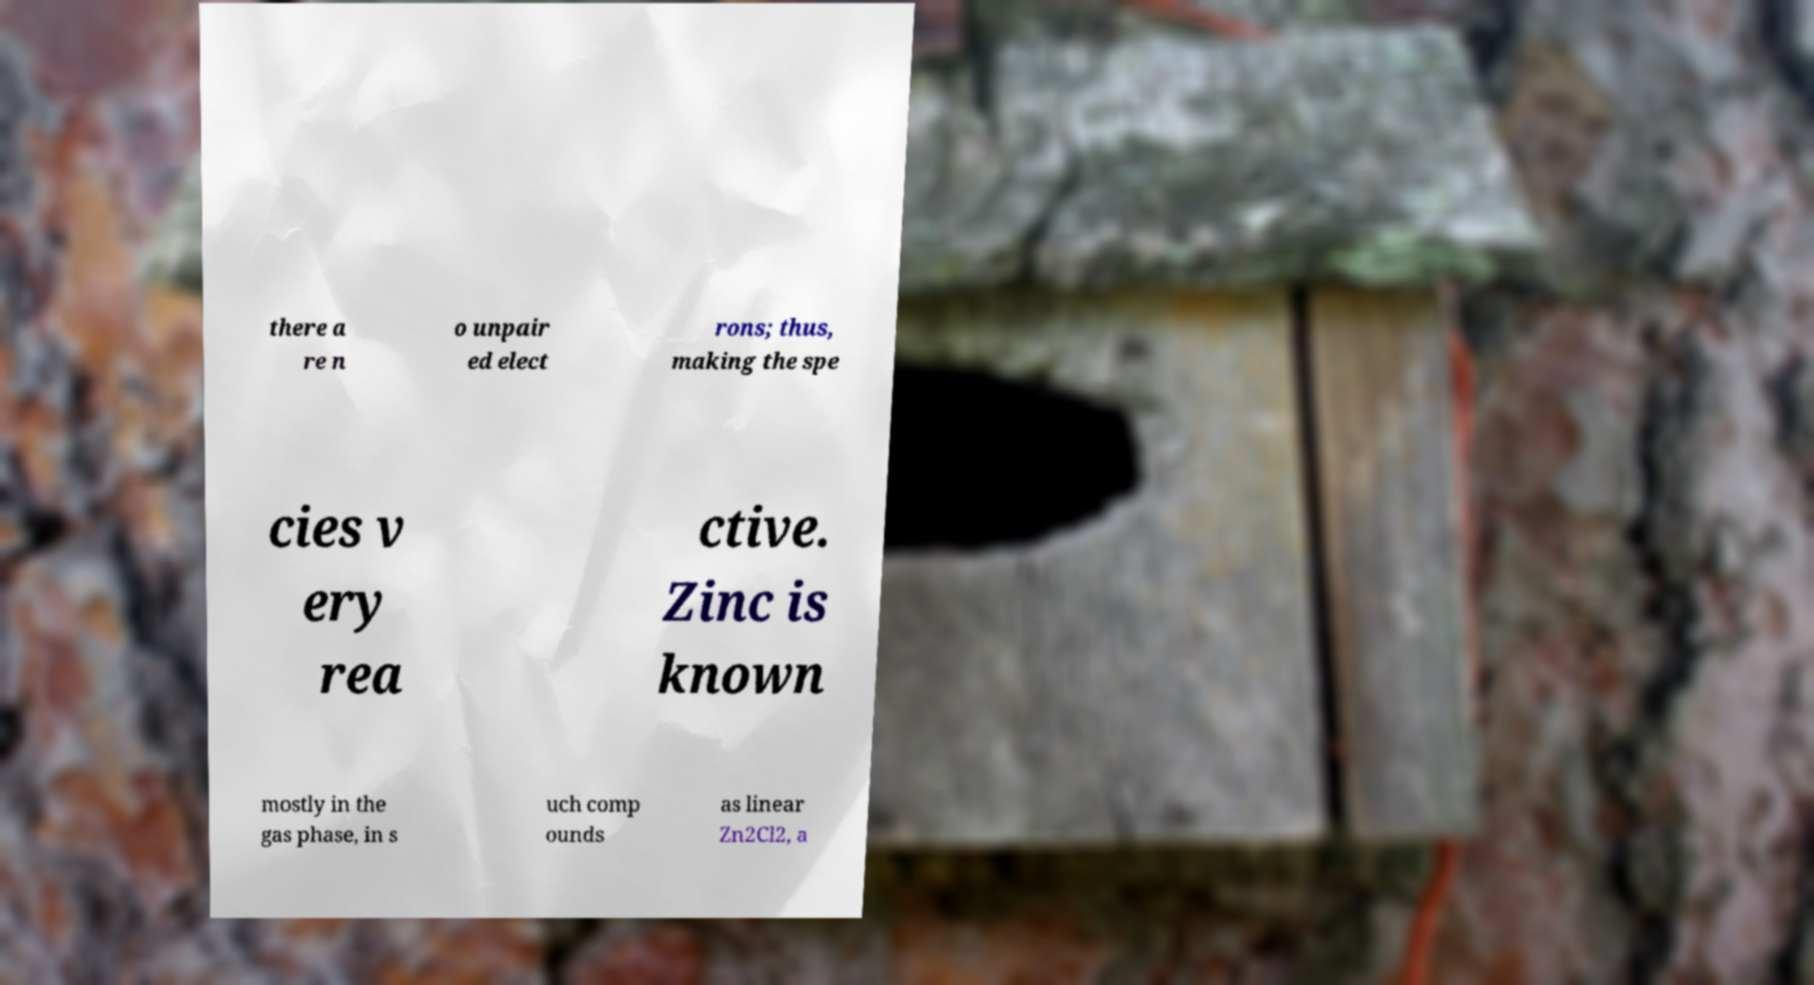Please identify and transcribe the text found in this image. there a re n o unpair ed elect rons; thus, making the spe cies v ery rea ctive. Zinc is known mostly in the gas phase, in s uch comp ounds as linear Zn2Cl2, a 